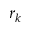Convert formula to latex. <formula><loc_0><loc_0><loc_500><loc_500>r _ { k }</formula> 